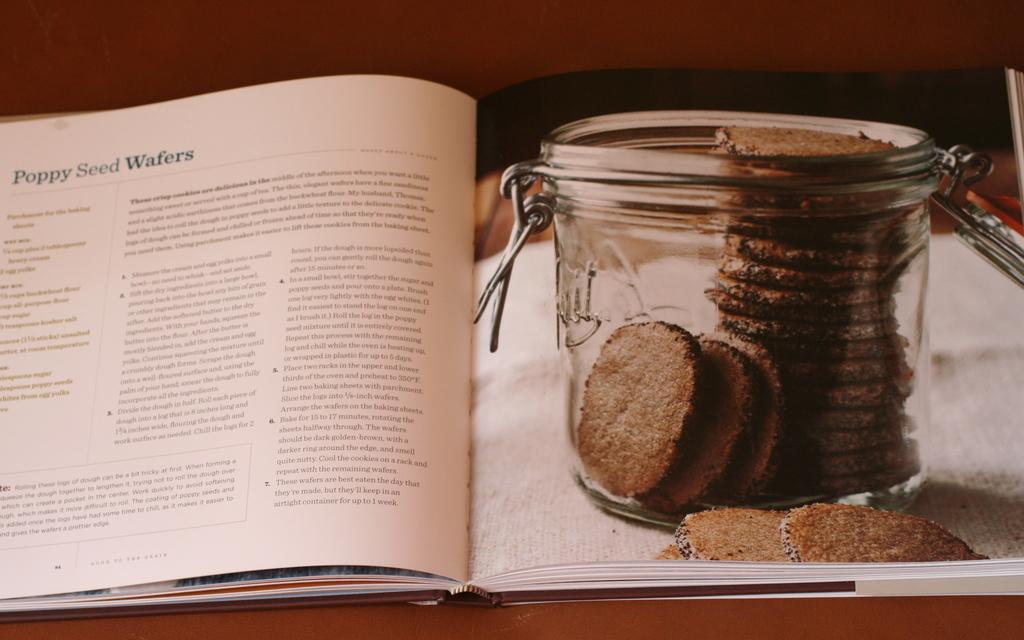Provide a one-sentence caption for the provided image. A book open to a recipe for Poppy Seed Wafers. 